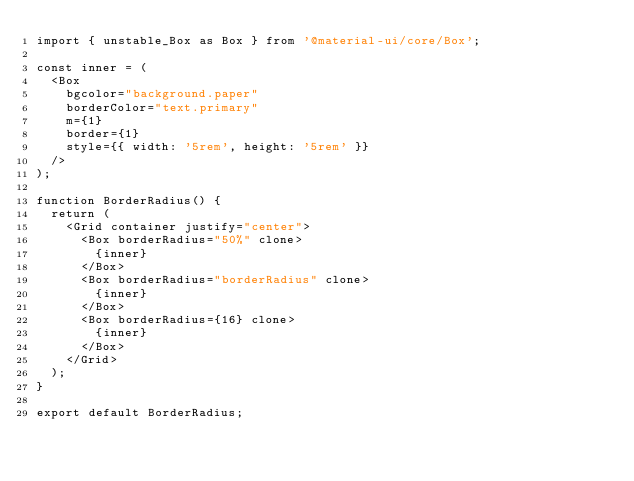Convert code to text. <code><loc_0><loc_0><loc_500><loc_500><_JavaScript_>import { unstable_Box as Box } from '@material-ui/core/Box';

const inner = (
  <Box
    bgcolor="background.paper"
    borderColor="text.primary"
    m={1}
    border={1}
    style={{ width: '5rem', height: '5rem' }}
  />
);

function BorderRadius() {
  return (
    <Grid container justify="center">
      <Box borderRadius="50%" clone>
        {inner}
      </Box>
      <Box borderRadius="borderRadius" clone>
        {inner}
      </Box>
      <Box borderRadius={16} clone>
        {inner}
      </Box>
    </Grid>
  );
}

export default BorderRadius;
</code> 